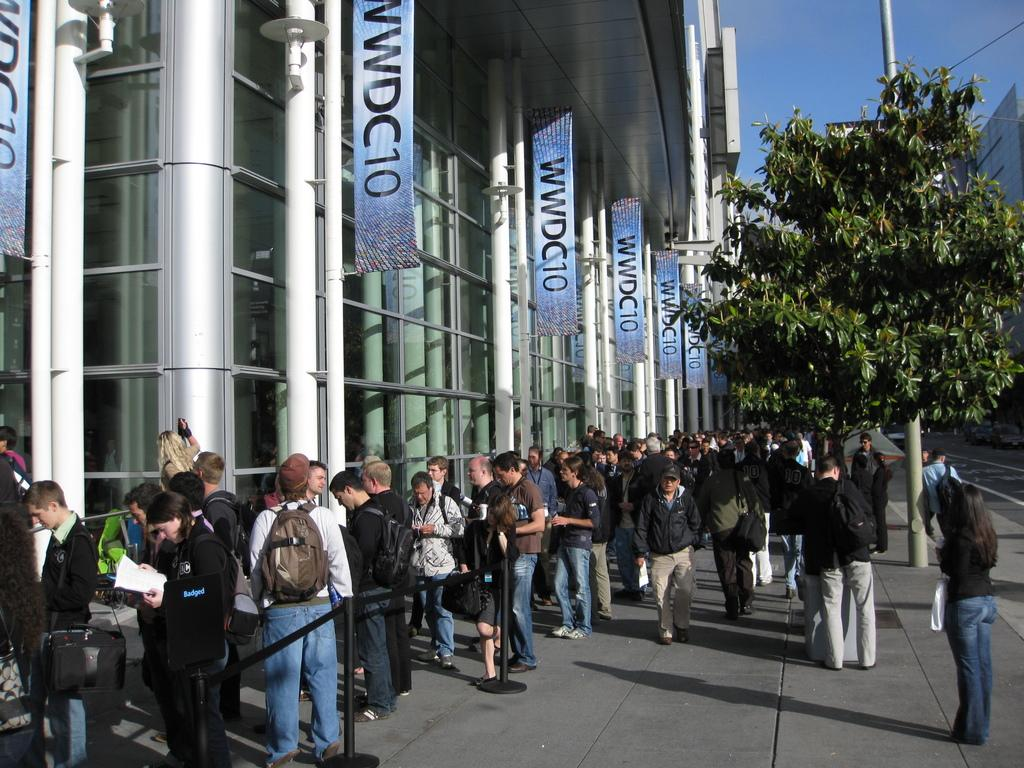<image>
Describe the image concisely. People lined up under banners that say WWDC10 